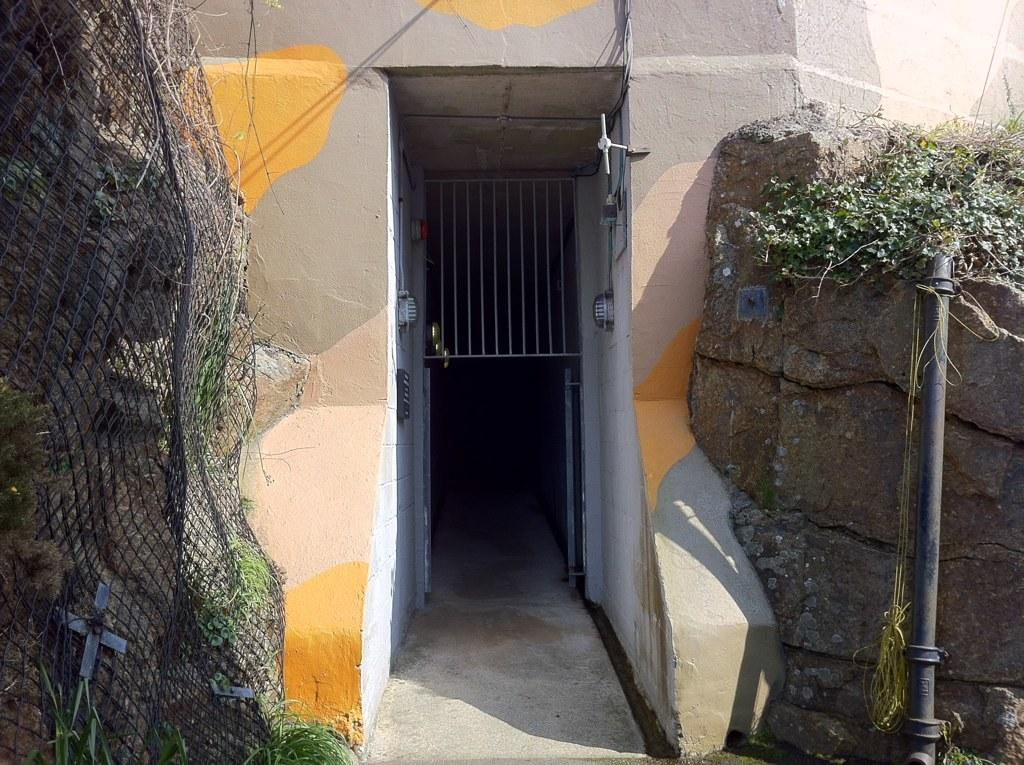What type of structure is present in the image? There is a building in the image. What colors can be seen on the building? The building has cream, gray, and yellow colors. What is located in front of the building? There are plants in front of the building. What color are the plants? The plants are green. What can be seen in the background of the image? There is a railing visible in the background. What type of tub is visible in the image? There is no tub present in the image. What type of polish is being applied to the plants in the image? There is no polish being applied to the plants in the image; they are simply green plants. 